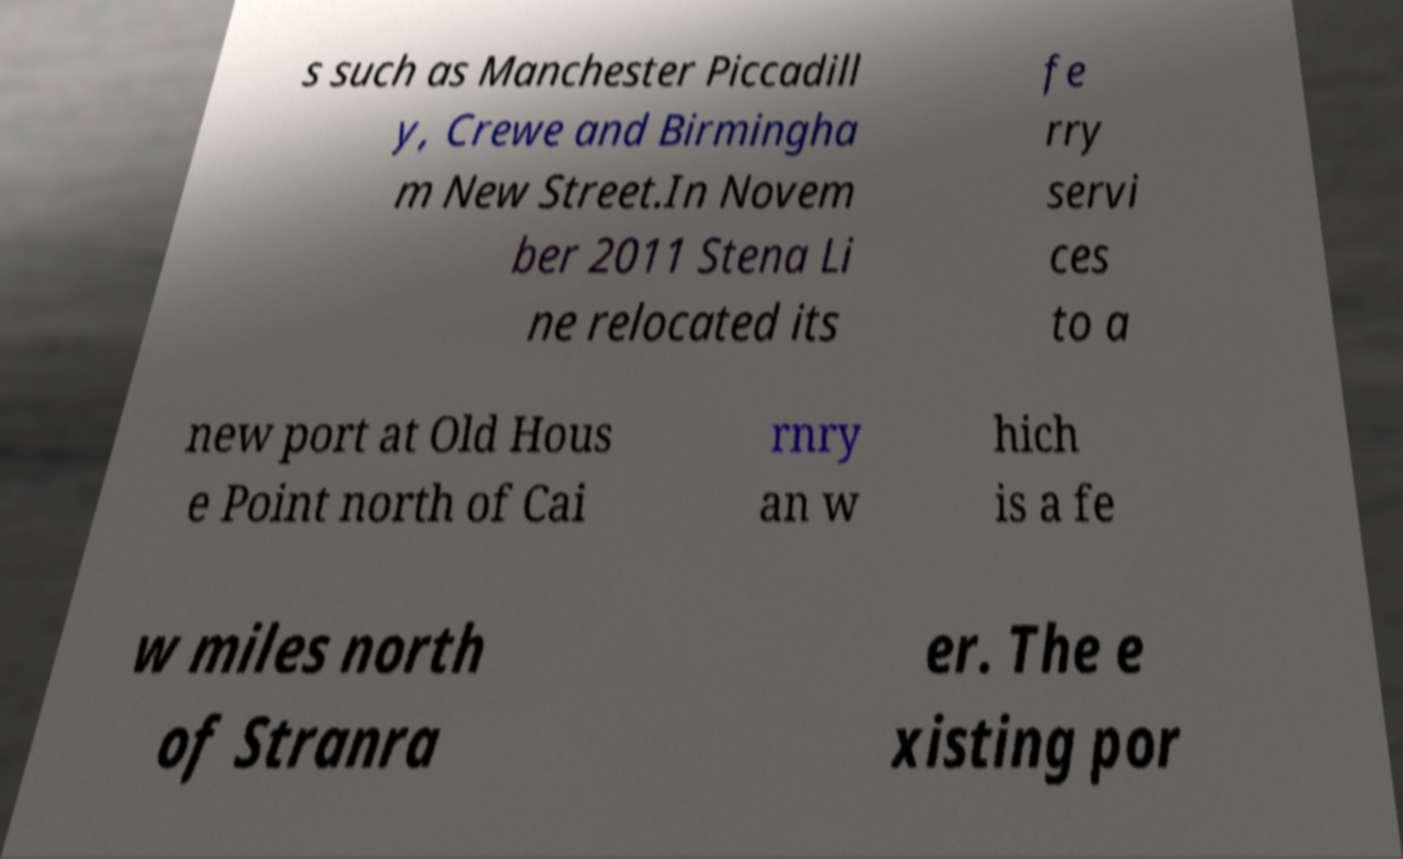Can you read and provide the text displayed in the image?This photo seems to have some interesting text. Can you extract and type it out for me? s such as Manchester Piccadill y, Crewe and Birmingha m New Street.In Novem ber 2011 Stena Li ne relocated its fe rry servi ces to a new port at Old Hous e Point north of Cai rnry an w hich is a fe w miles north of Stranra er. The e xisting por 